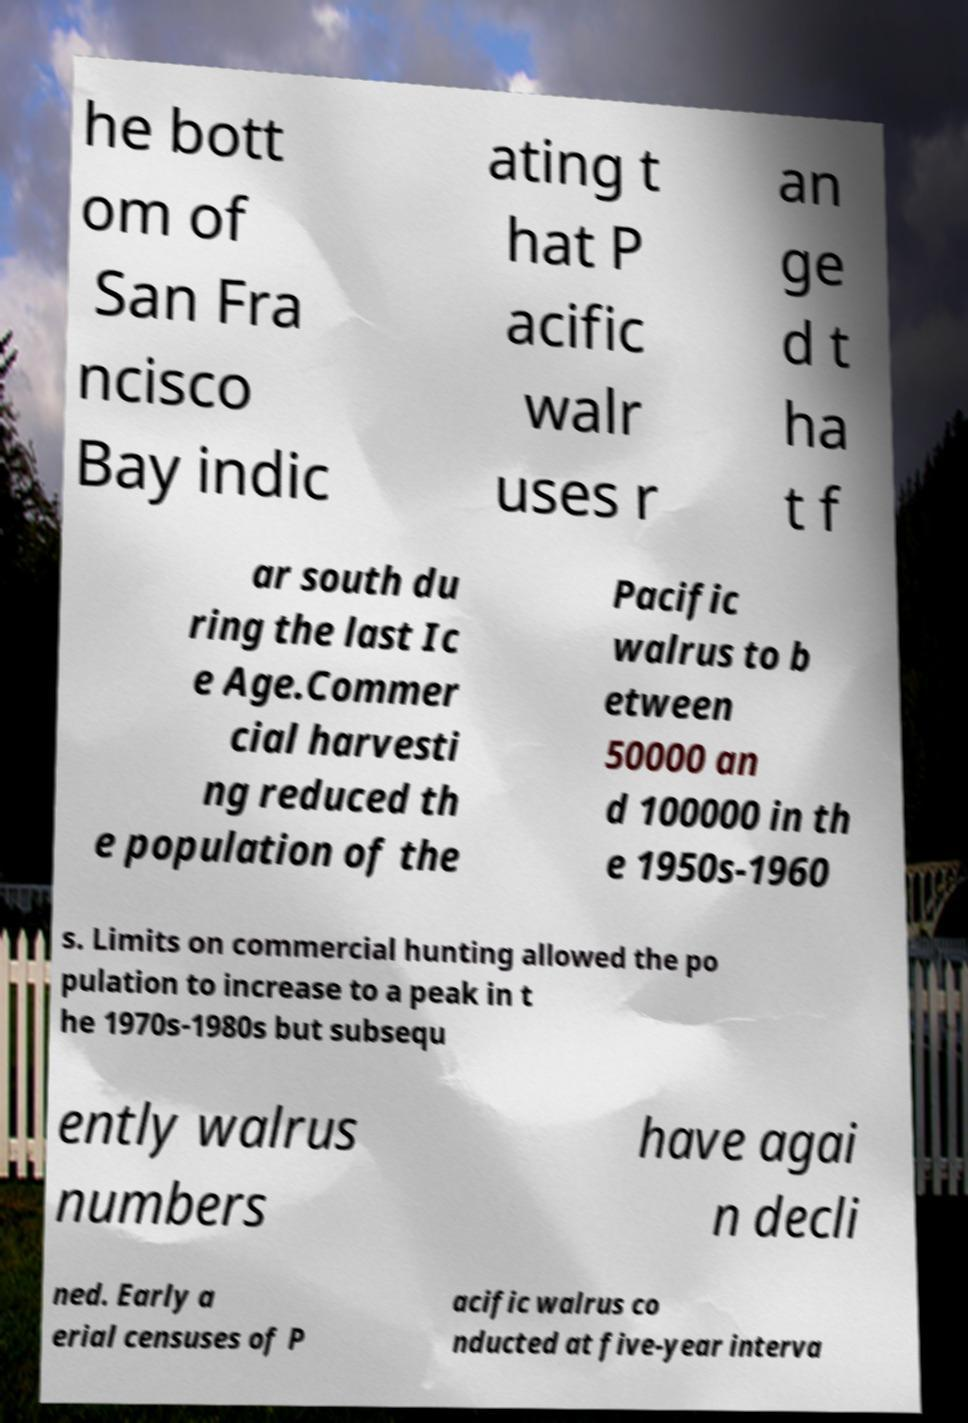Can you accurately transcribe the text from the provided image for me? he bott om of San Fra ncisco Bay indic ating t hat P acific walr uses r an ge d t ha t f ar south du ring the last Ic e Age.Commer cial harvesti ng reduced th e population of the Pacific walrus to b etween 50000 an d 100000 in th e 1950s-1960 s. Limits on commercial hunting allowed the po pulation to increase to a peak in t he 1970s-1980s but subsequ ently walrus numbers have agai n decli ned. Early a erial censuses of P acific walrus co nducted at five-year interva 